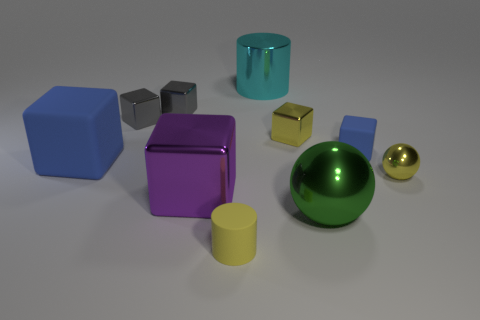What colors are represented among the objects in this image? The image features objects in various colors including blue, purple, gray, teal, yellow, green, and gold. 